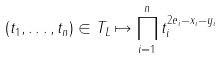<formula> <loc_0><loc_0><loc_500><loc_500>( t _ { 1 } , \dots , t _ { n } ) \in T _ { L } \mapsto \prod _ { i = 1 } ^ { n } t _ { i } ^ { 2 e _ { i } - x _ { i } - y _ { i } }</formula> 